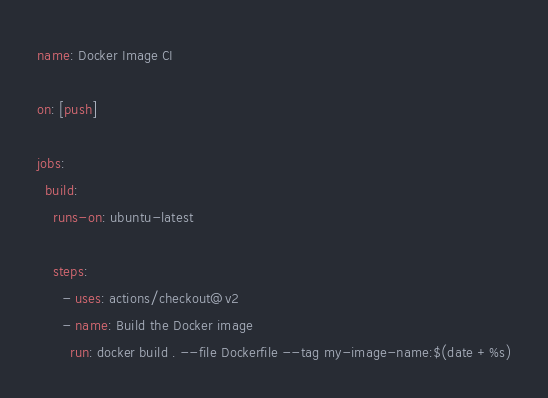Convert code to text. <code><loc_0><loc_0><loc_500><loc_500><_YAML_>name: Docker Image CI

on: [push]

jobs:
  build:
    runs-on: ubuntu-latest

    steps:
      - uses: actions/checkout@v2
      - name: Build the Docker image
        run: docker build . --file Dockerfile --tag my-image-name:$(date +%s)
</code> 